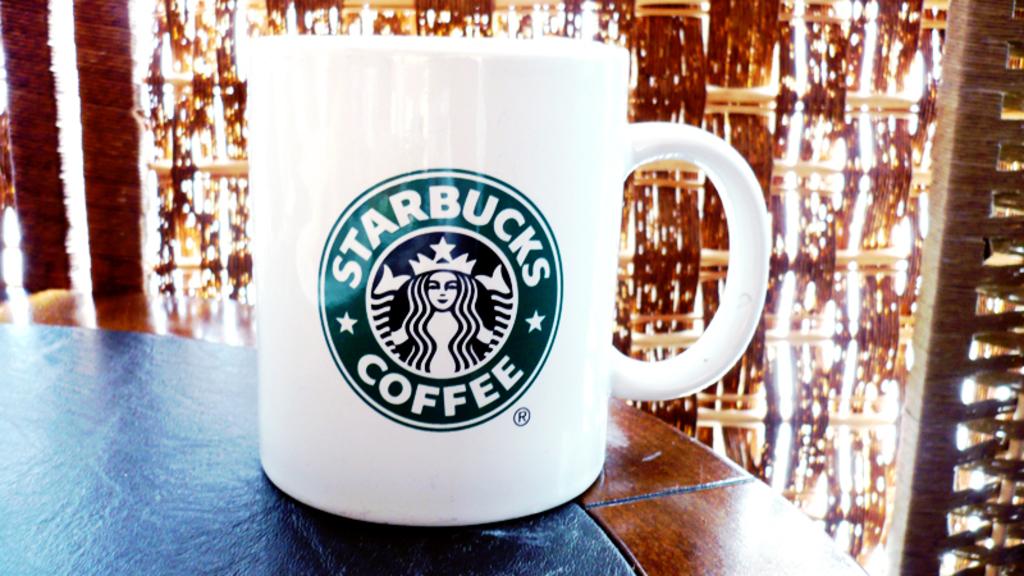What brand is this coffee?
Give a very brief answer. Starbucks. 